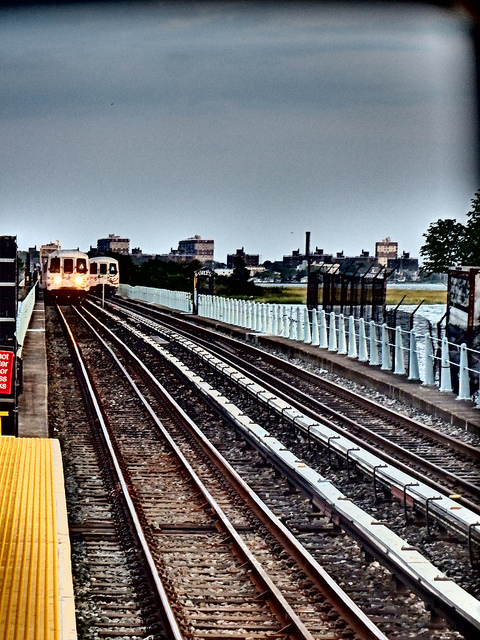<image>Are there people on the train? It is unknown if there are people on the train. Are there people on the train? I am not sure if there are people on the train. It can be both yes or no. 